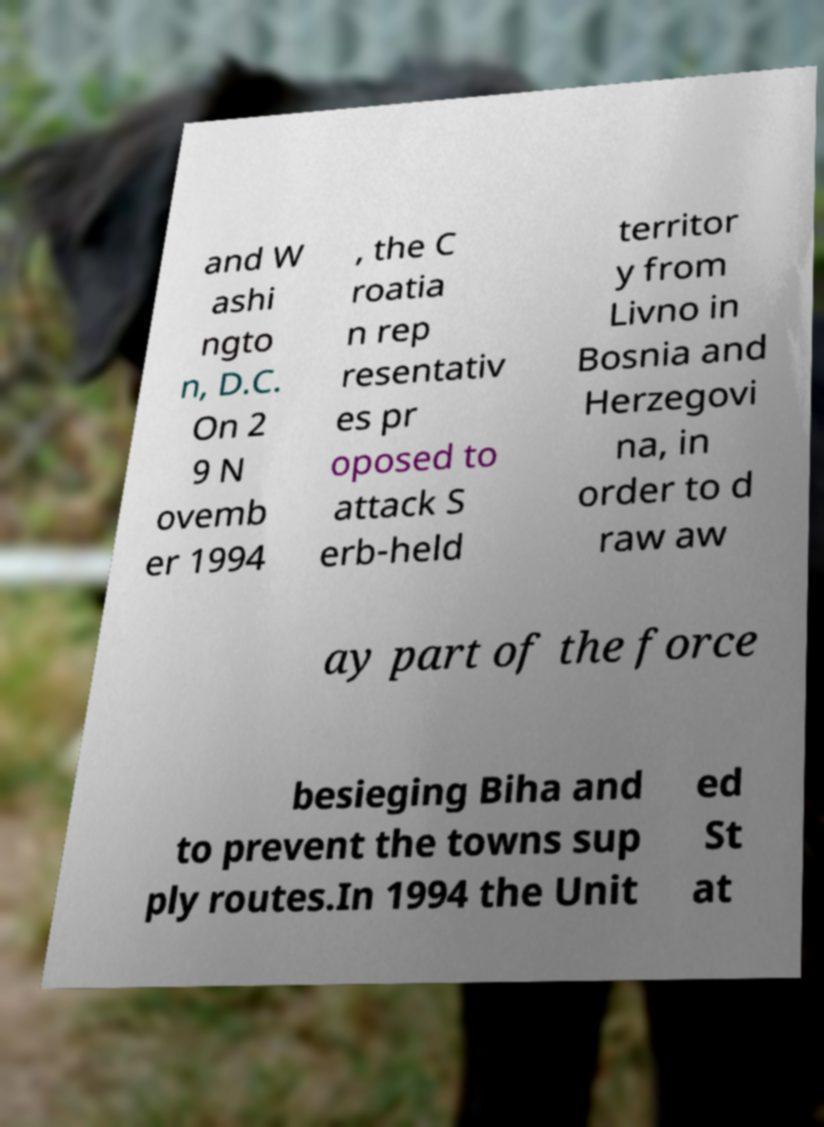Please identify and transcribe the text found in this image. and W ashi ngto n, D.C. On 2 9 N ovemb er 1994 , the C roatia n rep resentativ es pr oposed to attack S erb-held territor y from Livno in Bosnia and Herzegovi na, in order to d raw aw ay part of the force besieging Biha and to prevent the towns sup ply routes.In 1994 the Unit ed St at 